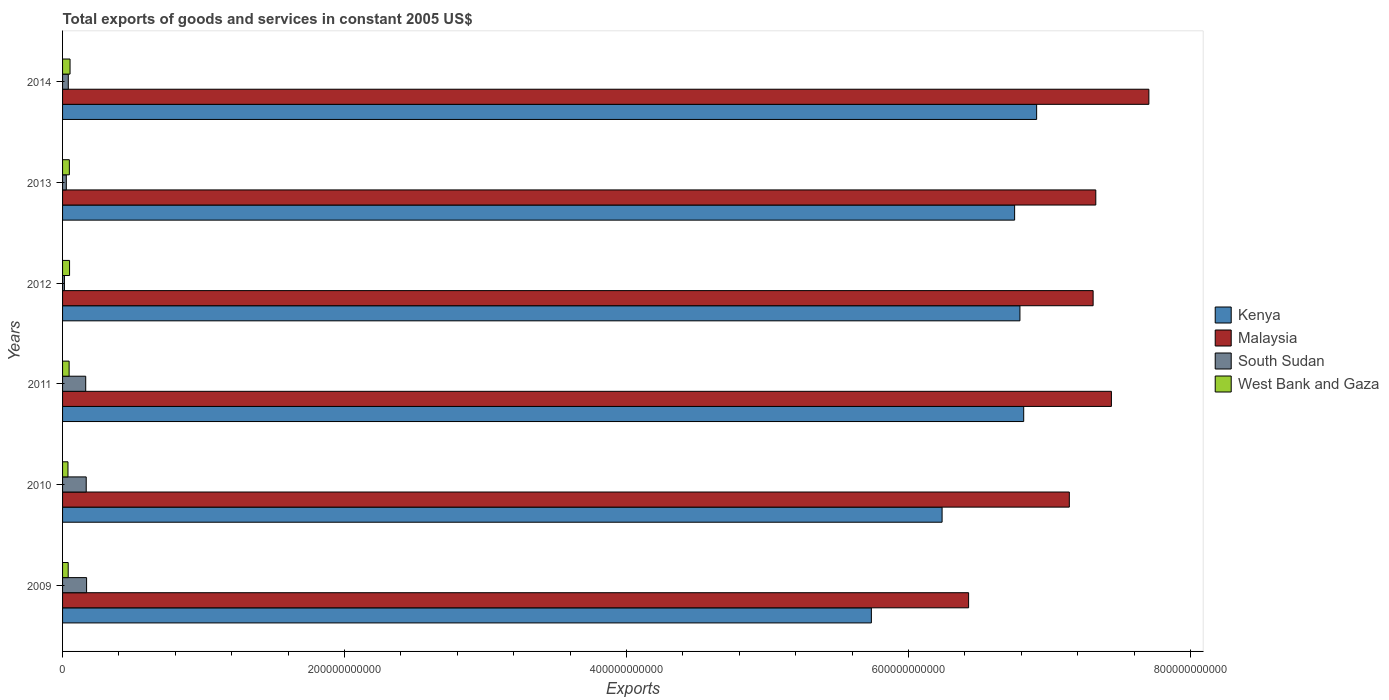How many different coloured bars are there?
Offer a terse response. 4. Are the number of bars on each tick of the Y-axis equal?
Provide a short and direct response. Yes. How many bars are there on the 5th tick from the top?
Your answer should be compact. 4. What is the label of the 3rd group of bars from the top?
Provide a succinct answer. 2012. What is the total exports of goods and services in Kenya in 2009?
Your answer should be very brief. 5.74e+11. Across all years, what is the maximum total exports of goods and services in West Bank and Gaza?
Provide a short and direct response. 5.31e+09. Across all years, what is the minimum total exports of goods and services in South Sudan?
Ensure brevity in your answer.  1.33e+09. What is the total total exports of goods and services in Kenya in the graph?
Offer a very short reply. 3.92e+12. What is the difference between the total exports of goods and services in Kenya in 2010 and that in 2012?
Offer a very short reply. -5.52e+1. What is the difference between the total exports of goods and services in Malaysia in 2009 and the total exports of goods and services in South Sudan in 2012?
Your answer should be very brief. 6.41e+11. What is the average total exports of goods and services in Kenya per year?
Your response must be concise. 6.54e+11. In the year 2014, what is the difference between the total exports of goods and services in West Bank and Gaza and total exports of goods and services in South Sudan?
Provide a short and direct response. 1.24e+09. In how many years, is the total exports of goods and services in South Sudan greater than 360000000000 US$?
Give a very brief answer. 0. What is the ratio of the total exports of goods and services in Kenya in 2011 to that in 2014?
Your answer should be very brief. 0.99. What is the difference between the highest and the second highest total exports of goods and services in Kenya?
Offer a terse response. 9.18e+09. What is the difference between the highest and the lowest total exports of goods and services in Malaysia?
Provide a short and direct response. 1.28e+11. Is the sum of the total exports of goods and services in South Sudan in 2013 and 2014 greater than the maximum total exports of goods and services in Malaysia across all years?
Your response must be concise. No. Is it the case that in every year, the sum of the total exports of goods and services in Kenya and total exports of goods and services in Malaysia is greater than the sum of total exports of goods and services in South Sudan and total exports of goods and services in West Bank and Gaza?
Give a very brief answer. Yes. What does the 1st bar from the top in 2013 represents?
Your answer should be compact. West Bank and Gaza. What does the 3rd bar from the bottom in 2011 represents?
Offer a very short reply. South Sudan. Is it the case that in every year, the sum of the total exports of goods and services in Kenya and total exports of goods and services in West Bank and Gaza is greater than the total exports of goods and services in South Sudan?
Your response must be concise. Yes. How many bars are there?
Offer a very short reply. 24. How many years are there in the graph?
Provide a succinct answer. 6. What is the difference between two consecutive major ticks on the X-axis?
Provide a short and direct response. 2.00e+11. Does the graph contain grids?
Your answer should be very brief. No. Where does the legend appear in the graph?
Offer a terse response. Center right. How many legend labels are there?
Your answer should be very brief. 4. What is the title of the graph?
Your response must be concise. Total exports of goods and services in constant 2005 US$. What is the label or title of the X-axis?
Provide a succinct answer. Exports. What is the Exports in Kenya in 2009?
Offer a very short reply. 5.74e+11. What is the Exports of Malaysia in 2009?
Keep it short and to the point. 6.43e+11. What is the Exports of South Sudan in 2009?
Provide a succinct answer. 1.70e+1. What is the Exports of West Bank and Gaza in 2009?
Offer a terse response. 4.00e+09. What is the Exports in Kenya in 2010?
Provide a succinct answer. 6.24e+11. What is the Exports of Malaysia in 2010?
Offer a very short reply. 7.14e+11. What is the Exports in South Sudan in 2010?
Offer a very short reply. 1.68e+1. What is the Exports in West Bank and Gaza in 2010?
Your response must be concise. 3.85e+09. What is the Exports of Kenya in 2011?
Provide a short and direct response. 6.82e+11. What is the Exports of Malaysia in 2011?
Keep it short and to the point. 7.44e+11. What is the Exports of South Sudan in 2011?
Ensure brevity in your answer.  1.64e+1. What is the Exports in West Bank and Gaza in 2011?
Your answer should be compact. 4.65e+09. What is the Exports in Kenya in 2012?
Provide a succinct answer. 6.79e+11. What is the Exports of Malaysia in 2012?
Your answer should be compact. 7.31e+11. What is the Exports of South Sudan in 2012?
Your answer should be compact. 1.33e+09. What is the Exports in West Bank and Gaza in 2012?
Your response must be concise. 4.97e+09. What is the Exports in Kenya in 2013?
Ensure brevity in your answer.  6.75e+11. What is the Exports in Malaysia in 2013?
Make the answer very short. 7.33e+11. What is the Exports of South Sudan in 2013?
Provide a short and direct response. 2.66e+09. What is the Exports of West Bank and Gaza in 2013?
Ensure brevity in your answer.  4.81e+09. What is the Exports in Kenya in 2014?
Your response must be concise. 6.91e+11. What is the Exports of Malaysia in 2014?
Ensure brevity in your answer.  7.71e+11. What is the Exports in South Sudan in 2014?
Ensure brevity in your answer.  4.06e+09. What is the Exports in West Bank and Gaza in 2014?
Offer a very short reply. 5.31e+09. Across all years, what is the maximum Exports of Kenya?
Your answer should be very brief. 6.91e+11. Across all years, what is the maximum Exports of Malaysia?
Give a very brief answer. 7.71e+11. Across all years, what is the maximum Exports of South Sudan?
Your response must be concise. 1.70e+1. Across all years, what is the maximum Exports of West Bank and Gaza?
Offer a terse response. 5.31e+09. Across all years, what is the minimum Exports of Kenya?
Make the answer very short. 5.74e+11. Across all years, what is the minimum Exports in Malaysia?
Provide a succinct answer. 6.43e+11. Across all years, what is the minimum Exports of South Sudan?
Keep it short and to the point. 1.33e+09. Across all years, what is the minimum Exports of West Bank and Gaza?
Ensure brevity in your answer.  3.85e+09. What is the total Exports of Kenya in the graph?
Offer a very short reply. 3.92e+12. What is the total Exports in Malaysia in the graph?
Your answer should be compact. 4.33e+12. What is the total Exports in South Sudan in the graph?
Ensure brevity in your answer.  5.83e+1. What is the total Exports in West Bank and Gaza in the graph?
Give a very brief answer. 2.76e+1. What is the difference between the Exports of Kenya in 2009 and that in 2010?
Your response must be concise. -5.02e+1. What is the difference between the Exports in Malaysia in 2009 and that in 2010?
Offer a very short reply. -7.14e+1. What is the difference between the Exports of South Sudan in 2009 and that in 2010?
Ensure brevity in your answer.  2.67e+08. What is the difference between the Exports in West Bank and Gaza in 2009 and that in 2010?
Provide a short and direct response. 1.52e+08. What is the difference between the Exports of Kenya in 2009 and that in 2011?
Provide a short and direct response. -1.08e+11. What is the difference between the Exports of Malaysia in 2009 and that in 2011?
Keep it short and to the point. -1.01e+11. What is the difference between the Exports in South Sudan in 2009 and that in 2011?
Give a very brief answer. 6.14e+08. What is the difference between the Exports of West Bank and Gaza in 2009 and that in 2011?
Provide a short and direct response. -6.48e+08. What is the difference between the Exports of Kenya in 2009 and that in 2012?
Make the answer very short. -1.05e+11. What is the difference between the Exports of Malaysia in 2009 and that in 2012?
Offer a terse response. -8.83e+1. What is the difference between the Exports of South Sudan in 2009 and that in 2012?
Make the answer very short. 1.57e+1. What is the difference between the Exports in West Bank and Gaza in 2009 and that in 2012?
Make the answer very short. -9.69e+08. What is the difference between the Exports of Kenya in 2009 and that in 2013?
Your answer should be very brief. -1.02e+11. What is the difference between the Exports of Malaysia in 2009 and that in 2013?
Keep it short and to the point. -9.02e+1. What is the difference between the Exports in South Sudan in 2009 and that in 2013?
Provide a short and direct response. 1.44e+1. What is the difference between the Exports of West Bank and Gaza in 2009 and that in 2013?
Give a very brief answer. -8.14e+08. What is the difference between the Exports of Kenya in 2009 and that in 2014?
Ensure brevity in your answer.  -1.17e+11. What is the difference between the Exports in Malaysia in 2009 and that in 2014?
Provide a short and direct response. -1.28e+11. What is the difference between the Exports in South Sudan in 2009 and that in 2014?
Keep it short and to the point. 1.30e+1. What is the difference between the Exports of West Bank and Gaza in 2009 and that in 2014?
Your answer should be very brief. -1.31e+09. What is the difference between the Exports in Kenya in 2010 and that in 2011?
Your response must be concise. -5.79e+1. What is the difference between the Exports of Malaysia in 2010 and that in 2011?
Give a very brief answer. -2.98e+1. What is the difference between the Exports of South Sudan in 2010 and that in 2011?
Ensure brevity in your answer.  3.47e+08. What is the difference between the Exports of West Bank and Gaza in 2010 and that in 2011?
Provide a short and direct response. -8.00e+08. What is the difference between the Exports of Kenya in 2010 and that in 2012?
Offer a very short reply. -5.52e+1. What is the difference between the Exports in Malaysia in 2010 and that in 2012?
Ensure brevity in your answer.  -1.69e+1. What is the difference between the Exports in South Sudan in 2010 and that in 2012?
Offer a very short reply. 1.54e+1. What is the difference between the Exports of West Bank and Gaza in 2010 and that in 2012?
Your answer should be compact. -1.12e+09. What is the difference between the Exports in Kenya in 2010 and that in 2013?
Provide a short and direct response. -5.14e+1. What is the difference between the Exports of Malaysia in 2010 and that in 2013?
Provide a short and direct response. -1.88e+1. What is the difference between the Exports in South Sudan in 2010 and that in 2013?
Keep it short and to the point. 1.41e+1. What is the difference between the Exports in West Bank and Gaza in 2010 and that in 2013?
Make the answer very short. -9.66e+08. What is the difference between the Exports in Kenya in 2010 and that in 2014?
Offer a very short reply. -6.71e+1. What is the difference between the Exports of Malaysia in 2010 and that in 2014?
Ensure brevity in your answer.  -5.64e+1. What is the difference between the Exports of South Sudan in 2010 and that in 2014?
Ensure brevity in your answer.  1.27e+1. What is the difference between the Exports in West Bank and Gaza in 2010 and that in 2014?
Ensure brevity in your answer.  -1.46e+09. What is the difference between the Exports in Kenya in 2011 and that in 2012?
Your answer should be very brief. 2.67e+09. What is the difference between the Exports in Malaysia in 2011 and that in 2012?
Provide a succinct answer. 1.30e+1. What is the difference between the Exports of South Sudan in 2011 and that in 2012?
Provide a succinct answer. 1.51e+1. What is the difference between the Exports in West Bank and Gaza in 2011 and that in 2012?
Offer a very short reply. -3.20e+08. What is the difference between the Exports in Kenya in 2011 and that in 2013?
Provide a succinct answer. 6.44e+09. What is the difference between the Exports in Malaysia in 2011 and that in 2013?
Offer a very short reply. 1.11e+1. What is the difference between the Exports in South Sudan in 2011 and that in 2013?
Keep it short and to the point. 1.38e+1. What is the difference between the Exports of West Bank and Gaza in 2011 and that in 2013?
Your response must be concise. -1.66e+08. What is the difference between the Exports in Kenya in 2011 and that in 2014?
Provide a short and direct response. -9.18e+09. What is the difference between the Exports of Malaysia in 2011 and that in 2014?
Offer a terse response. -2.66e+1. What is the difference between the Exports of South Sudan in 2011 and that in 2014?
Offer a terse response. 1.24e+1. What is the difference between the Exports in West Bank and Gaza in 2011 and that in 2014?
Keep it short and to the point. -6.61e+08. What is the difference between the Exports in Kenya in 2012 and that in 2013?
Your answer should be very brief. 3.77e+09. What is the difference between the Exports in Malaysia in 2012 and that in 2013?
Your answer should be compact. -1.90e+09. What is the difference between the Exports in South Sudan in 2012 and that in 2013?
Give a very brief answer. -1.33e+09. What is the difference between the Exports of West Bank and Gaza in 2012 and that in 2013?
Provide a succinct answer. 1.54e+08. What is the difference between the Exports in Kenya in 2012 and that in 2014?
Keep it short and to the point. -1.18e+1. What is the difference between the Exports of Malaysia in 2012 and that in 2014?
Ensure brevity in your answer.  -3.95e+1. What is the difference between the Exports in South Sudan in 2012 and that in 2014?
Your answer should be compact. -2.73e+09. What is the difference between the Exports in West Bank and Gaza in 2012 and that in 2014?
Your answer should be compact. -3.41e+08. What is the difference between the Exports of Kenya in 2013 and that in 2014?
Make the answer very short. -1.56e+1. What is the difference between the Exports in Malaysia in 2013 and that in 2014?
Provide a succinct answer. -3.76e+1. What is the difference between the Exports of South Sudan in 2013 and that in 2014?
Your answer should be compact. -1.40e+09. What is the difference between the Exports in West Bank and Gaza in 2013 and that in 2014?
Keep it short and to the point. -4.95e+08. What is the difference between the Exports of Kenya in 2009 and the Exports of Malaysia in 2010?
Ensure brevity in your answer.  -1.40e+11. What is the difference between the Exports in Kenya in 2009 and the Exports in South Sudan in 2010?
Give a very brief answer. 5.57e+11. What is the difference between the Exports of Kenya in 2009 and the Exports of West Bank and Gaza in 2010?
Your answer should be compact. 5.70e+11. What is the difference between the Exports in Malaysia in 2009 and the Exports in South Sudan in 2010?
Provide a succinct answer. 6.26e+11. What is the difference between the Exports in Malaysia in 2009 and the Exports in West Bank and Gaza in 2010?
Keep it short and to the point. 6.39e+11. What is the difference between the Exports in South Sudan in 2009 and the Exports in West Bank and Gaza in 2010?
Offer a terse response. 1.32e+1. What is the difference between the Exports in Kenya in 2009 and the Exports in Malaysia in 2011?
Make the answer very short. -1.70e+11. What is the difference between the Exports in Kenya in 2009 and the Exports in South Sudan in 2011?
Give a very brief answer. 5.57e+11. What is the difference between the Exports in Kenya in 2009 and the Exports in West Bank and Gaza in 2011?
Provide a succinct answer. 5.69e+11. What is the difference between the Exports in Malaysia in 2009 and the Exports in South Sudan in 2011?
Provide a short and direct response. 6.26e+11. What is the difference between the Exports of Malaysia in 2009 and the Exports of West Bank and Gaza in 2011?
Provide a short and direct response. 6.38e+11. What is the difference between the Exports in South Sudan in 2009 and the Exports in West Bank and Gaza in 2011?
Offer a very short reply. 1.24e+1. What is the difference between the Exports in Kenya in 2009 and the Exports in Malaysia in 2012?
Keep it short and to the point. -1.57e+11. What is the difference between the Exports in Kenya in 2009 and the Exports in South Sudan in 2012?
Offer a very short reply. 5.72e+11. What is the difference between the Exports of Kenya in 2009 and the Exports of West Bank and Gaza in 2012?
Provide a succinct answer. 5.69e+11. What is the difference between the Exports of Malaysia in 2009 and the Exports of South Sudan in 2012?
Your answer should be very brief. 6.41e+11. What is the difference between the Exports in Malaysia in 2009 and the Exports in West Bank and Gaza in 2012?
Your answer should be very brief. 6.38e+11. What is the difference between the Exports of South Sudan in 2009 and the Exports of West Bank and Gaza in 2012?
Provide a succinct answer. 1.21e+1. What is the difference between the Exports in Kenya in 2009 and the Exports in Malaysia in 2013?
Your answer should be compact. -1.59e+11. What is the difference between the Exports in Kenya in 2009 and the Exports in South Sudan in 2013?
Ensure brevity in your answer.  5.71e+11. What is the difference between the Exports in Kenya in 2009 and the Exports in West Bank and Gaza in 2013?
Your answer should be very brief. 5.69e+11. What is the difference between the Exports in Malaysia in 2009 and the Exports in South Sudan in 2013?
Provide a short and direct response. 6.40e+11. What is the difference between the Exports of Malaysia in 2009 and the Exports of West Bank and Gaza in 2013?
Offer a terse response. 6.38e+11. What is the difference between the Exports in South Sudan in 2009 and the Exports in West Bank and Gaza in 2013?
Offer a very short reply. 1.22e+1. What is the difference between the Exports in Kenya in 2009 and the Exports in Malaysia in 2014?
Offer a terse response. -1.97e+11. What is the difference between the Exports in Kenya in 2009 and the Exports in South Sudan in 2014?
Give a very brief answer. 5.70e+11. What is the difference between the Exports in Kenya in 2009 and the Exports in West Bank and Gaza in 2014?
Ensure brevity in your answer.  5.68e+11. What is the difference between the Exports of Malaysia in 2009 and the Exports of South Sudan in 2014?
Your answer should be compact. 6.39e+11. What is the difference between the Exports of Malaysia in 2009 and the Exports of West Bank and Gaza in 2014?
Offer a terse response. 6.37e+11. What is the difference between the Exports of South Sudan in 2009 and the Exports of West Bank and Gaza in 2014?
Your answer should be very brief. 1.17e+1. What is the difference between the Exports in Kenya in 2010 and the Exports in Malaysia in 2011?
Provide a succinct answer. -1.20e+11. What is the difference between the Exports of Kenya in 2010 and the Exports of South Sudan in 2011?
Keep it short and to the point. 6.07e+11. What is the difference between the Exports of Kenya in 2010 and the Exports of West Bank and Gaza in 2011?
Keep it short and to the point. 6.19e+11. What is the difference between the Exports in Malaysia in 2010 and the Exports in South Sudan in 2011?
Provide a succinct answer. 6.98e+11. What is the difference between the Exports in Malaysia in 2010 and the Exports in West Bank and Gaza in 2011?
Keep it short and to the point. 7.09e+11. What is the difference between the Exports of South Sudan in 2010 and the Exports of West Bank and Gaza in 2011?
Give a very brief answer. 1.21e+1. What is the difference between the Exports of Kenya in 2010 and the Exports of Malaysia in 2012?
Your answer should be very brief. -1.07e+11. What is the difference between the Exports in Kenya in 2010 and the Exports in South Sudan in 2012?
Your response must be concise. 6.23e+11. What is the difference between the Exports in Kenya in 2010 and the Exports in West Bank and Gaza in 2012?
Offer a terse response. 6.19e+11. What is the difference between the Exports in Malaysia in 2010 and the Exports in South Sudan in 2012?
Offer a terse response. 7.13e+11. What is the difference between the Exports of Malaysia in 2010 and the Exports of West Bank and Gaza in 2012?
Keep it short and to the point. 7.09e+11. What is the difference between the Exports in South Sudan in 2010 and the Exports in West Bank and Gaza in 2012?
Give a very brief answer. 1.18e+1. What is the difference between the Exports in Kenya in 2010 and the Exports in Malaysia in 2013?
Ensure brevity in your answer.  -1.09e+11. What is the difference between the Exports of Kenya in 2010 and the Exports of South Sudan in 2013?
Offer a very short reply. 6.21e+11. What is the difference between the Exports in Kenya in 2010 and the Exports in West Bank and Gaza in 2013?
Your response must be concise. 6.19e+11. What is the difference between the Exports of Malaysia in 2010 and the Exports of South Sudan in 2013?
Ensure brevity in your answer.  7.11e+11. What is the difference between the Exports of Malaysia in 2010 and the Exports of West Bank and Gaza in 2013?
Provide a succinct answer. 7.09e+11. What is the difference between the Exports in South Sudan in 2010 and the Exports in West Bank and Gaza in 2013?
Your answer should be very brief. 1.20e+1. What is the difference between the Exports of Kenya in 2010 and the Exports of Malaysia in 2014?
Ensure brevity in your answer.  -1.47e+11. What is the difference between the Exports of Kenya in 2010 and the Exports of South Sudan in 2014?
Ensure brevity in your answer.  6.20e+11. What is the difference between the Exports of Kenya in 2010 and the Exports of West Bank and Gaza in 2014?
Offer a terse response. 6.19e+11. What is the difference between the Exports in Malaysia in 2010 and the Exports in South Sudan in 2014?
Offer a very short reply. 7.10e+11. What is the difference between the Exports in Malaysia in 2010 and the Exports in West Bank and Gaza in 2014?
Your answer should be compact. 7.09e+11. What is the difference between the Exports in South Sudan in 2010 and the Exports in West Bank and Gaza in 2014?
Your answer should be compact. 1.15e+1. What is the difference between the Exports in Kenya in 2011 and the Exports in Malaysia in 2012?
Keep it short and to the point. -4.92e+1. What is the difference between the Exports of Kenya in 2011 and the Exports of South Sudan in 2012?
Provide a succinct answer. 6.80e+11. What is the difference between the Exports of Kenya in 2011 and the Exports of West Bank and Gaza in 2012?
Your response must be concise. 6.77e+11. What is the difference between the Exports in Malaysia in 2011 and the Exports in South Sudan in 2012?
Offer a terse response. 7.43e+11. What is the difference between the Exports in Malaysia in 2011 and the Exports in West Bank and Gaza in 2012?
Your response must be concise. 7.39e+11. What is the difference between the Exports of South Sudan in 2011 and the Exports of West Bank and Gaza in 2012?
Offer a terse response. 1.15e+1. What is the difference between the Exports in Kenya in 2011 and the Exports in Malaysia in 2013?
Provide a succinct answer. -5.11e+1. What is the difference between the Exports in Kenya in 2011 and the Exports in South Sudan in 2013?
Your response must be concise. 6.79e+11. What is the difference between the Exports of Kenya in 2011 and the Exports of West Bank and Gaza in 2013?
Give a very brief answer. 6.77e+11. What is the difference between the Exports in Malaysia in 2011 and the Exports in South Sudan in 2013?
Offer a terse response. 7.41e+11. What is the difference between the Exports of Malaysia in 2011 and the Exports of West Bank and Gaza in 2013?
Offer a terse response. 7.39e+11. What is the difference between the Exports of South Sudan in 2011 and the Exports of West Bank and Gaza in 2013?
Provide a short and direct response. 1.16e+1. What is the difference between the Exports in Kenya in 2011 and the Exports in Malaysia in 2014?
Give a very brief answer. -8.88e+1. What is the difference between the Exports of Kenya in 2011 and the Exports of South Sudan in 2014?
Your answer should be compact. 6.78e+11. What is the difference between the Exports of Kenya in 2011 and the Exports of West Bank and Gaza in 2014?
Your answer should be compact. 6.76e+11. What is the difference between the Exports of Malaysia in 2011 and the Exports of South Sudan in 2014?
Offer a terse response. 7.40e+11. What is the difference between the Exports of Malaysia in 2011 and the Exports of West Bank and Gaza in 2014?
Ensure brevity in your answer.  7.39e+11. What is the difference between the Exports of South Sudan in 2011 and the Exports of West Bank and Gaza in 2014?
Your response must be concise. 1.11e+1. What is the difference between the Exports in Kenya in 2012 and the Exports in Malaysia in 2013?
Your answer should be compact. -5.38e+1. What is the difference between the Exports in Kenya in 2012 and the Exports in South Sudan in 2013?
Keep it short and to the point. 6.76e+11. What is the difference between the Exports in Kenya in 2012 and the Exports in West Bank and Gaza in 2013?
Your answer should be compact. 6.74e+11. What is the difference between the Exports in Malaysia in 2012 and the Exports in South Sudan in 2013?
Provide a short and direct response. 7.28e+11. What is the difference between the Exports of Malaysia in 2012 and the Exports of West Bank and Gaza in 2013?
Keep it short and to the point. 7.26e+11. What is the difference between the Exports of South Sudan in 2012 and the Exports of West Bank and Gaza in 2013?
Provide a short and direct response. -3.48e+09. What is the difference between the Exports of Kenya in 2012 and the Exports of Malaysia in 2014?
Make the answer very short. -9.15e+1. What is the difference between the Exports of Kenya in 2012 and the Exports of South Sudan in 2014?
Your answer should be very brief. 6.75e+11. What is the difference between the Exports of Kenya in 2012 and the Exports of West Bank and Gaza in 2014?
Provide a succinct answer. 6.74e+11. What is the difference between the Exports in Malaysia in 2012 and the Exports in South Sudan in 2014?
Ensure brevity in your answer.  7.27e+11. What is the difference between the Exports of Malaysia in 2012 and the Exports of West Bank and Gaza in 2014?
Offer a terse response. 7.26e+11. What is the difference between the Exports of South Sudan in 2012 and the Exports of West Bank and Gaza in 2014?
Keep it short and to the point. -3.98e+09. What is the difference between the Exports of Kenya in 2013 and the Exports of Malaysia in 2014?
Your response must be concise. -9.52e+1. What is the difference between the Exports in Kenya in 2013 and the Exports in South Sudan in 2014?
Keep it short and to the point. 6.71e+11. What is the difference between the Exports in Kenya in 2013 and the Exports in West Bank and Gaza in 2014?
Keep it short and to the point. 6.70e+11. What is the difference between the Exports of Malaysia in 2013 and the Exports of South Sudan in 2014?
Provide a succinct answer. 7.29e+11. What is the difference between the Exports in Malaysia in 2013 and the Exports in West Bank and Gaza in 2014?
Keep it short and to the point. 7.28e+11. What is the difference between the Exports of South Sudan in 2013 and the Exports of West Bank and Gaza in 2014?
Make the answer very short. -2.65e+09. What is the average Exports in Kenya per year?
Give a very brief answer. 6.54e+11. What is the average Exports of Malaysia per year?
Provide a succinct answer. 7.22e+11. What is the average Exports of South Sudan per year?
Your answer should be very brief. 9.72e+09. What is the average Exports in West Bank and Gaza per year?
Offer a terse response. 4.60e+09. In the year 2009, what is the difference between the Exports in Kenya and Exports in Malaysia?
Offer a very short reply. -6.90e+1. In the year 2009, what is the difference between the Exports in Kenya and Exports in South Sudan?
Offer a very short reply. 5.57e+11. In the year 2009, what is the difference between the Exports of Kenya and Exports of West Bank and Gaza?
Your answer should be very brief. 5.70e+11. In the year 2009, what is the difference between the Exports of Malaysia and Exports of South Sudan?
Offer a terse response. 6.26e+11. In the year 2009, what is the difference between the Exports in Malaysia and Exports in West Bank and Gaza?
Your answer should be very brief. 6.39e+11. In the year 2009, what is the difference between the Exports of South Sudan and Exports of West Bank and Gaza?
Your answer should be compact. 1.30e+1. In the year 2010, what is the difference between the Exports of Kenya and Exports of Malaysia?
Provide a short and direct response. -9.02e+1. In the year 2010, what is the difference between the Exports of Kenya and Exports of South Sudan?
Ensure brevity in your answer.  6.07e+11. In the year 2010, what is the difference between the Exports in Kenya and Exports in West Bank and Gaza?
Offer a terse response. 6.20e+11. In the year 2010, what is the difference between the Exports in Malaysia and Exports in South Sudan?
Provide a succinct answer. 6.97e+11. In the year 2010, what is the difference between the Exports of Malaysia and Exports of West Bank and Gaza?
Ensure brevity in your answer.  7.10e+11. In the year 2010, what is the difference between the Exports of South Sudan and Exports of West Bank and Gaza?
Give a very brief answer. 1.29e+1. In the year 2011, what is the difference between the Exports of Kenya and Exports of Malaysia?
Your answer should be compact. -6.22e+1. In the year 2011, what is the difference between the Exports of Kenya and Exports of South Sudan?
Offer a terse response. 6.65e+11. In the year 2011, what is the difference between the Exports in Kenya and Exports in West Bank and Gaza?
Ensure brevity in your answer.  6.77e+11. In the year 2011, what is the difference between the Exports of Malaysia and Exports of South Sudan?
Ensure brevity in your answer.  7.27e+11. In the year 2011, what is the difference between the Exports of Malaysia and Exports of West Bank and Gaza?
Your answer should be very brief. 7.39e+11. In the year 2011, what is the difference between the Exports of South Sudan and Exports of West Bank and Gaza?
Offer a terse response. 1.18e+1. In the year 2012, what is the difference between the Exports of Kenya and Exports of Malaysia?
Your answer should be very brief. -5.19e+1. In the year 2012, what is the difference between the Exports in Kenya and Exports in South Sudan?
Your response must be concise. 6.78e+11. In the year 2012, what is the difference between the Exports of Kenya and Exports of West Bank and Gaza?
Keep it short and to the point. 6.74e+11. In the year 2012, what is the difference between the Exports in Malaysia and Exports in South Sudan?
Offer a very short reply. 7.30e+11. In the year 2012, what is the difference between the Exports of Malaysia and Exports of West Bank and Gaza?
Provide a succinct answer. 7.26e+11. In the year 2012, what is the difference between the Exports in South Sudan and Exports in West Bank and Gaza?
Provide a succinct answer. -3.64e+09. In the year 2013, what is the difference between the Exports in Kenya and Exports in Malaysia?
Offer a terse response. -5.76e+1. In the year 2013, what is the difference between the Exports of Kenya and Exports of South Sudan?
Provide a succinct answer. 6.73e+11. In the year 2013, what is the difference between the Exports in Kenya and Exports in West Bank and Gaza?
Provide a succinct answer. 6.70e+11. In the year 2013, what is the difference between the Exports of Malaysia and Exports of South Sudan?
Offer a terse response. 7.30e+11. In the year 2013, what is the difference between the Exports in Malaysia and Exports in West Bank and Gaza?
Ensure brevity in your answer.  7.28e+11. In the year 2013, what is the difference between the Exports in South Sudan and Exports in West Bank and Gaza?
Your answer should be very brief. -2.15e+09. In the year 2014, what is the difference between the Exports in Kenya and Exports in Malaysia?
Give a very brief answer. -7.96e+1. In the year 2014, what is the difference between the Exports of Kenya and Exports of South Sudan?
Offer a very short reply. 6.87e+11. In the year 2014, what is the difference between the Exports of Kenya and Exports of West Bank and Gaza?
Keep it short and to the point. 6.86e+11. In the year 2014, what is the difference between the Exports in Malaysia and Exports in South Sudan?
Keep it short and to the point. 7.66e+11. In the year 2014, what is the difference between the Exports in Malaysia and Exports in West Bank and Gaza?
Make the answer very short. 7.65e+11. In the year 2014, what is the difference between the Exports of South Sudan and Exports of West Bank and Gaza?
Keep it short and to the point. -1.24e+09. What is the ratio of the Exports of Kenya in 2009 to that in 2010?
Offer a very short reply. 0.92. What is the ratio of the Exports of South Sudan in 2009 to that in 2010?
Provide a succinct answer. 1.02. What is the ratio of the Exports of West Bank and Gaza in 2009 to that in 2010?
Provide a short and direct response. 1.04. What is the ratio of the Exports of Kenya in 2009 to that in 2011?
Offer a terse response. 0.84. What is the ratio of the Exports in Malaysia in 2009 to that in 2011?
Provide a short and direct response. 0.86. What is the ratio of the Exports of South Sudan in 2009 to that in 2011?
Provide a succinct answer. 1.04. What is the ratio of the Exports in West Bank and Gaza in 2009 to that in 2011?
Keep it short and to the point. 0.86. What is the ratio of the Exports of Kenya in 2009 to that in 2012?
Keep it short and to the point. 0.84. What is the ratio of the Exports in Malaysia in 2009 to that in 2012?
Provide a short and direct response. 0.88. What is the ratio of the Exports of South Sudan in 2009 to that in 2012?
Offer a terse response. 12.78. What is the ratio of the Exports in West Bank and Gaza in 2009 to that in 2012?
Ensure brevity in your answer.  0.81. What is the ratio of the Exports of Kenya in 2009 to that in 2013?
Ensure brevity in your answer.  0.85. What is the ratio of the Exports of Malaysia in 2009 to that in 2013?
Offer a very short reply. 0.88. What is the ratio of the Exports of South Sudan in 2009 to that in 2013?
Keep it short and to the point. 6.41. What is the ratio of the Exports of West Bank and Gaza in 2009 to that in 2013?
Your response must be concise. 0.83. What is the ratio of the Exports of Kenya in 2009 to that in 2014?
Your response must be concise. 0.83. What is the ratio of the Exports in Malaysia in 2009 to that in 2014?
Provide a short and direct response. 0.83. What is the ratio of the Exports of South Sudan in 2009 to that in 2014?
Your answer should be very brief. 4.19. What is the ratio of the Exports of West Bank and Gaza in 2009 to that in 2014?
Your answer should be very brief. 0.75. What is the ratio of the Exports of Kenya in 2010 to that in 2011?
Keep it short and to the point. 0.92. What is the ratio of the Exports in Malaysia in 2010 to that in 2011?
Make the answer very short. 0.96. What is the ratio of the Exports in South Sudan in 2010 to that in 2011?
Offer a very short reply. 1.02. What is the ratio of the Exports in West Bank and Gaza in 2010 to that in 2011?
Provide a succinct answer. 0.83. What is the ratio of the Exports of Kenya in 2010 to that in 2012?
Ensure brevity in your answer.  0.92. What is the ratio of the Exports of Malaysia in 2010 to that in 2012?
Give a very brief answer. 0.98. What is the ratio of the Exports in South Sudan in 2010 to that in 2012?
Your response must be concise. 12.58. What is the ratio of the Exports of West Bank and Gaza in 2010 to that in 2012?
Give a very brief answer. 0.77. What is the ratio of the Exports in Kenya in 2010 to that in 2013?
Make the answer very short. 0.92. What is the ratio of the Exports of Malaysia in 2010 to that in 2013?
Offer a terse response. 0.97. What is the ratio of the Exports in South Sudan in 2010 to that in 2013?
Offer a very short reply. 6.31. What is the ratio of the Exports in West Bank and Gaza in 2010 to that in 2013?
Your answer should be compact. 0.8. What is the ratio of the Exports of Kenya in 2010 to that in 2014?
Give a very brief answer. 0.9. What is the ratio of the Exports of Malaysia in 2010 to that in 2014?
Provide a succinct answer. 0.93. What is the ratio of the Exports of South Sudan in 2010 to that in 2014?
Keep it short and to the point. 4.13. What is the ratio of the Exports of West Bank and Gaza in 2010 to that in 2014?
Your response must be concise. 0.72. What is the ratio of the Exports of Kenya in 2011 to that in 2012?
Provide a short and direct response. 1. What is the ratio of the Exports of Malaysia in 2011 to that in 2012?
Your answer should be very brief. 1.02. What is the ratio of the Exports of South Sudan in 2011 to that in 2012?
Ensure brevity in your answer.  12.32. What is the ratio of the Exports of West Bank and Gaza in 2011 to that in 2012?
Your answer should be very brief. 0.94. What is the ratio of the Exports in Kenya in 2011 to that in 2013?
Offer a terse response. 1.01. What is the ratio of the Exports in Malaysia in 2011 to that in 2013?
Make the answer very short. 1.02. What is the ratio of the Exports of South Sudan in 2011 to that in 2013?
Ensure brevity in your answer.  6.18. What is the ratio of the Exports in West Bank and Gaza in 2011 to that in 2013?
Keep it short and to the point. 0.97. What is the ratio of the Exports in Kenya in 2011 to that in 2014?
Keep it short and to the point. 0.99. What is the ratio of the Exports in Malaysia in 2011 to that in 2014?
Your answer should be very brief. 0.97. What is the ratio of the Exports in South Sudan in 2011 to that in 2014?
Keep it short and to the point. 4.04. What is the ratio of the Exports in West Bank and Gaza in 2011 to that in 2014?
Your response must be concise. 0.88. What is the ratio of the Exports in Kenya in 2012 to that in 2013?
Provide a succinct answer. 1.01. What is the ratio of the Exports of Malaysia in 2012 to that in 2013?
Give a very brief answer. 1. What is the ratio of the Exports of South Sudan in 2012 to that in 2013?
Keep it short and to the point. 0.5. What is the ratio of the Exports in West Bank and Gaza in 2012 to that in 2013?
Provide a short and direct response. 1.03. What is the ratio of the Exports in Kenya in 2012 to that in 2014?
Ensure brevity in your answer.  0.98. What is the ratio of the Exports of Malaysia in 2012 to that in 2014?
Make the answer very short. 0.95. What is the ratio of the Exports in South Sudan in 2012 to that in 2014?
Provide a succinct answer. 0.33. What is the ratio of the Exports in West Bank and Gaza in 2012 to that in 2014?
Your answer should be compact. 0.94. What is the ratio of the Exports in Kenya in 2013 to that in 2014?
Ensure brevity in your answer.  0.98. What is the ratio of the Exports in Malaysia in 2013 to that in 2014?
Ensure brevity in your answer.  0.95. What is the ratio of the Exports in South Sudan in 2013 to that in 2014?
Make the answer very short. 0.65. What is the ratio of the Exports of West Bank and Gaza in 2013 to that in 2014?
Provide a short and direct response. 0.91. What is the difference between the highest and the second highest Exports in Kenya?
Ensure brevity in your answer.  9.18e+09. What is the difference between the highest and the second highest Exports in Malaysia?
Your answer should be compact. 2.66e+1. What is the difference between the highest and the second highest Exports in South Sudan?
Offer a terse response. 2.67e+08. What is the difference between the highest and the second highest Exports of West Bank and Gaza?
Offer a terse response. 3.41e+08. What is the difference between the highest and the lowest Exports of Kenya?
Provide a succinct answer. 1.17e+11. What is the difference between the highest and the lowest Exports in Malaysia?
Your response must be concise. 1.28e+11. What is the difference between the highest and the lowest Exports in South Sudan?
Offer a terse response. 1.57e+1. What is the difference between the highest and the lowest Exports in West Bank and Gaza?
Offer a terse response. 1.46e+09. 